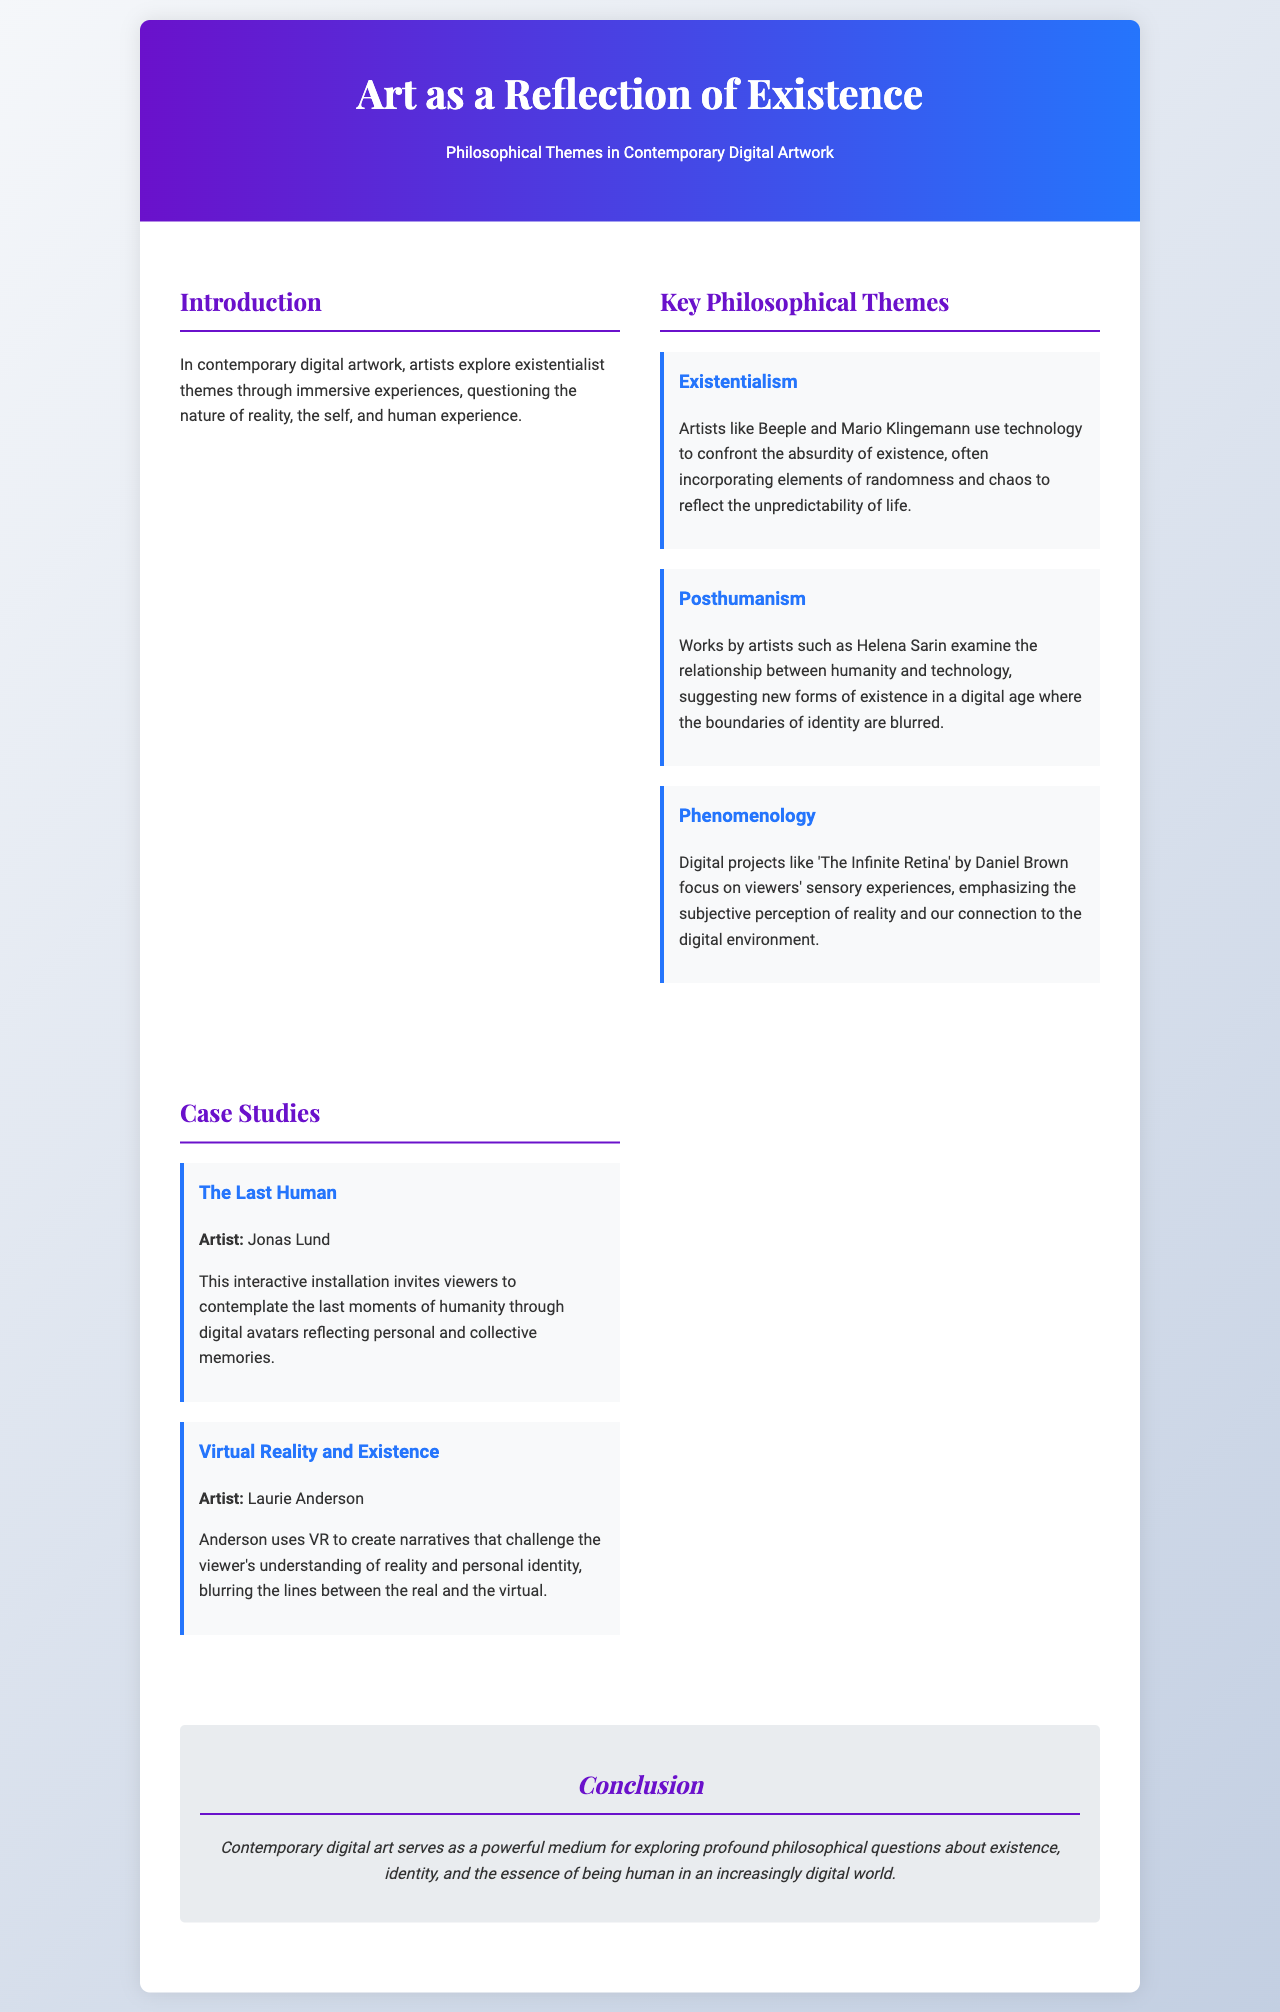What is the title of the brochure? The title appears at the top of the document, indicating the overall theme of the content presented.
Answer: Art as a Reflection of Existence Who is the artist of "The Last Human"? The document provides the name of the artist associated with this specific case study within the brochure.
Answer: Jonas Lund What theme explores the relationship between humanity and technology? This theme focuses on the implications of technology in relation to human identity and existence as described in the key philosophical themes.
Answer: Posthumanism What is the key focus of "The Infinite Retina"? This project is mentioned in relation to emphasizing how we perceive reality, connecting to viewers' experiences.
Answer: Sensory experiences Which artist uses virtual reality to challenge understanding of reality? The document describes the artist's use of VR to explore and challenge personal identity visually.
Answer: Laurie Anderson How many key philosophical themes are discussed? This question asks for the number of themes provided in the document, which outlines primary ideas explored in the artwork.
Answer: Three What does the conclusion emphasize about contemporary digital art? The conclusion summarizes the broader implications of digital art as a medium for philosophical exploration.
Answer: Questions about existence What style of the document is used in the header? This question inquires about the aesthetic choice made for the header section, which communicates the brochure's theme.
Answer: Gradient background 